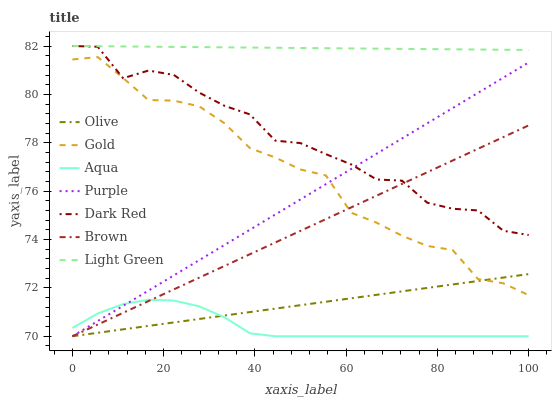Does Aqua have the minimum area under the curve?
Answer yes or no. Yes. Does Light Green have the maximum area under the curve?
Answer yes or no. Yes. Does Gold have the minimum area under the curve?
Answer yes or no. No. Does Gold have the maximum area under the curve?
Answer yes or no. No. Is Light Green the smoothest?
Answer yes or no. Yes. Is Dark Red the roughest?
Answer yes or no. Yes. Is Gold the smoothest?
Answer yes or no. No. Is Gold the roughest?
Answer yes or no. No. Does Brown have the lowest value?
Answer yes or no. Yes. Does Gold have the lowest value?
Answer yes or no. No. Does Light Green have the highest value?
Answer yes or no. Yes. Does Gold have the highest value?
Answer yes or no. No. Is Olive less than Light Green?
Answer yes or no. Yes. Is Light Green greater than Gold?
Answer yes or no. Yes. Does Light Green intersect Dark Red?
Answer yes or no. Yes. Is Light Green less than Dark Red?
Answer yes or no. No. Is Light Green greater than Dark Red?
Answer yes or no. No. Does Olive intersect Light Green?
Answer yes or no. No. 